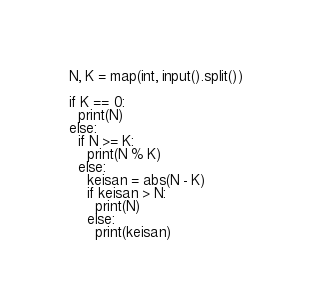<code> <loc_0><loc_0><loc_500><loc_500><_Python_>N, K = map(int, input().split())

if K == 0:
  print(N)
else:
  if N >= K:
    print(N % K)
  else:
    keisan = abs(N - K)
    if keisan > N:
      print(N)
    else:
      print(keisan)</code> 